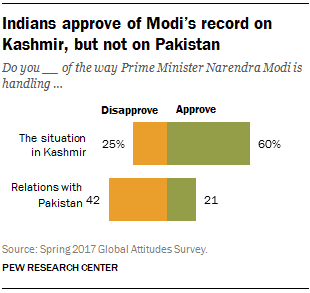Specify some key components in this picture. On average, the approval rate in both situations is 40.5%. The approval rate on the Kashmir situation is 60%. 